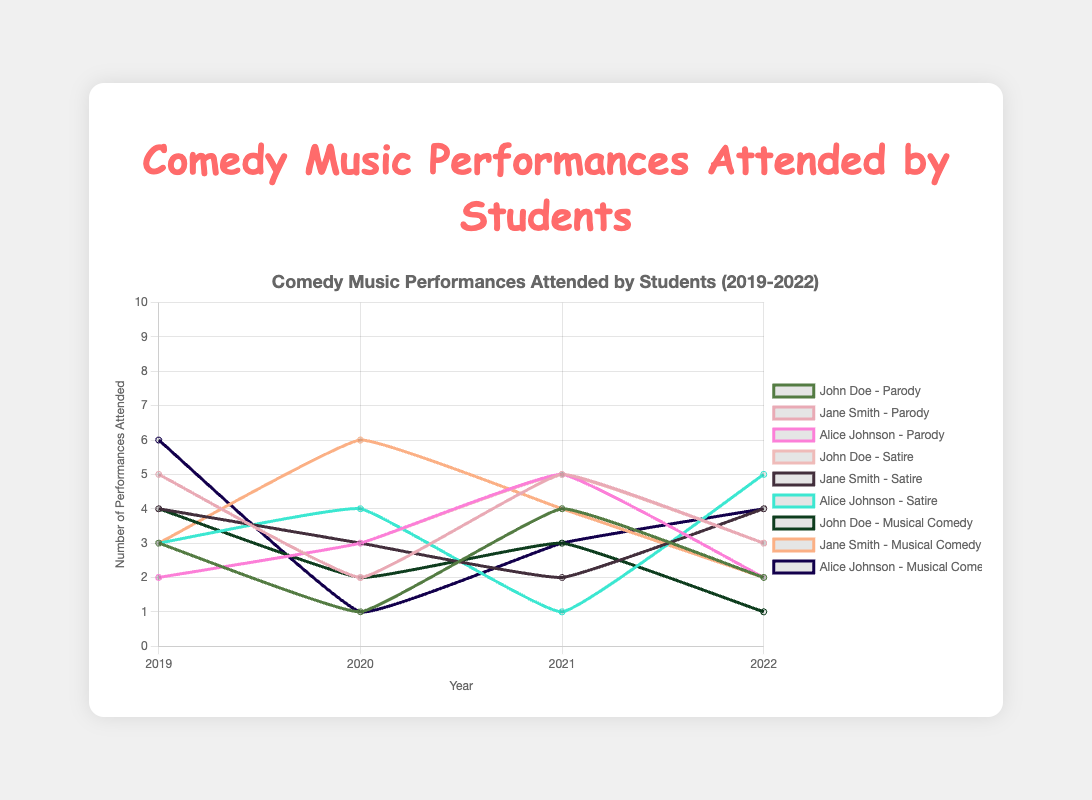What was the total number of parody performances attended by John Doe over the 4 years? Sum the number of parody performances attended by John Doe for each year: 3 (2019) + 1 (2020) + 4 (2021) + 2 (2022). Thus, the total is 3+1+4+2 = 10.
Answer: 10 How did Alice Johnson’s attendance for satire performances change from 2019 to 2022? Compare the numbers: In 2019, Alice attended 3 satire performances. In 2022, she attended 5 satire performances. Thus, it increased from 3 to 5.
Answer: Increased from 3 to 5 Which student attended the most musical comedy performances in 2020? Refer to the data from 2020: John Doe (2), Jane Smith (6), Alice Johnson (1). Jane Smith attended the most musical comedy performances.
Answer: Jane Smith Between 2019 and 2020, which genre saw the greatest decrease in the number of performances attended by Jane Smith? Compare the change in the number of performances attended by Jane Smith between 2019 and 2020 for each genre: Parody: 5 to 2, Satire: 4 to 3, Musical Comedy: 3 to 6. Parody saw the greatest decrease, from 5 to 2.
Answer: Parody What is the trend for satire performances attended by John Doe over the 4 years? Check the number of satire performances attended by John Doe each year: 2 (2019), 3 (2020), 5 (2021), 3 (2022). There is an initial increase from 2 to 5, followed by a decrease to 3.
Answer: Initial increase, then decrease Did the attendance for musical comedy performances by Alice Johnson increase or decrease from 2019 to 2022? In 2019, Alice attended 6 musical comedy performances. In 2022, she attended 4. Thus, it decreased.
Answer: Decreased Among the three students, who attended the highest number of comedy performances in total in 2021? Compare the total number of all comedy performances attended by each student in 2021: John Doe (4+5+3=12), Jane Smith (5+2+4=11), Alice Johnson (5+1+3=9). John Doe attended the highest number.
Answer: John Doe Which genre had the most stable attendance trend over the years for Jane Smith? Compare Jane Smith’s attendance for each genre across the years: Parody: 5, 2, 5, 3, Satire: 4, 3, 2, 4, Musical Comedy: 3, 6, 4, 2. Satire had the smallest variation.
Answer: Satire In which year did Alice Johnson attend the highest number of comedy performances, regardless of genre? Sum Alice Johnson's attendance for all genres per year: 2019 (2+3+6=11), 2020 (3+4+1=8), 2021 (5+1+3=9), 2022 (2+5+4=11). She attended the highest number (11) in 2019 and 2022.
Answer: 2019 and 2022 How did the total number of attended performances for all genres by all students change from 2019 to 2022? Sum performance attendance by all students for 2019 (3+5+2+2+4+3+4+3+6=32) and 2022 (2+3+2+3+4+5+1+2+4=26). Compare totals: 32 (2019) to 26 (2022), indicating a decrease.
Answer: Decreased 